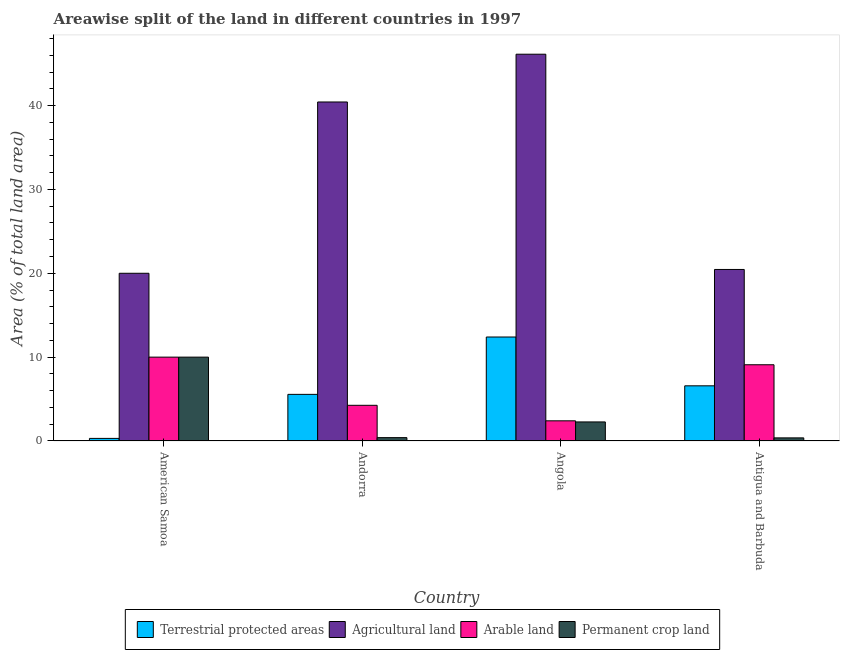How many different coloured bars are there?
Offer a very short reply. 4. Are the number of bars per tick equal to the number of legend labels?
Provide a short and direct response. Yes. How many bars are there on the 4th tick from the left?
Your answer should be very brief. 4. What is the label of the 4th group of bars from the left?
Offer a terse response. Antigua and Barbuda. What is the percentage of land under terrestrial protection in Antigua and Barbuda?
Make the answer very short. 6.58. Across all countries, what is the maximum percentage of area under permanent crop land?
Keep it short and to the point. 10. In which country was the percentage of land under terrestrial protection maximum?
Ensure brevity in your answer.  Angola. In which country was the percentage of area under agricultural land minimum?
Ensure brevity in your answer.  American Samoa. What is the total percentage of land under terrestrial protection in the graph?
Make the answer very short. 24.85. What is the difference between the percentage of area under agricultural land in Andorra and that in Antigua and Barbuda?
Make the answer very short. 19.97. What is the difference between the percentage of land under terrestrial protection in Angola and the percentage of area under permanent crop land in Andorra?
Your response must be concise. 12. What is the average percentage of area under agricultural land per country?
Provide a short and direct response. 31.75. What is the difference between the percentage of land under terrestrial protection and percentage of area under arable land in Andorra?
Keep it short and to the point. 1.3. In how many countries, is the percentage of area under permanent crop land greater than 26 %?
Make the answer very short. 0. What is the ratio of the percentage of area under agricultural land in American Samoa to that in Andorra?
Offer a very short reply. 0.49. Is the difference between the percentage of area under agricultural land in American Samoa and Andorra greater than the difference between the percentage of land under terrestrial protection in American Samoa and Andorra?
Your response must be concise. No. What is the difference between the highest and the second highest percentage of land under terrestrial protection?
Your answer should be compact. 5.82. What is the difference between the highest and the lowest percentage of area under arable land?
Make the answer very short. 7.59. Is it the case that in every country, the sum of the percentage of land under terrestrial protection and percentage of area under permanent crop land is greater than the sum of percentage of area under agricultural land and percentage of area under arable land?
Offer a terse response. Yes. What does the 3rd bar from the left in American Samoa represents?
Make the answer very short. Arable land. What does the 2nd bar from the right in American Samoa represents?
Your response must be concise. Arable land. Is it the case that in every country, the sum of the percentage of land under terrestrial protection and percentage of area under agricultural land is greater than the percentage of area under arable land?
Offer a very short reply. Yes. How many countries are there in the graph?
Give a very brief answer. 4. What is the difference between two consecutive major ticks on the Y-axis?
Offer a very short reply. 10. Are the values on the major ticks of Y-axis written in scientific E-notation?
Your response must be concise. No. Where does the legend appear in the graph?
Provide a short and direct response. Bottom center. How many legend labels are there?
Provide a short and direct response. 4. What is the title of the graph?
Your answer should be compact. Areawise split of the land in different countries in 1997. Does "Forest" appear as one of the legend labels in the graph?
Your response must be concise. No. What is the label or title of the Y-axis?
Your response must be concise. Area (% of total land area). What is the Area (% of total land area) of Terrestrial protected areas in American Samoa?
Give a very brief answer. 0.31. What is the Area (% of total land area) in Agricultural land in American Samoa?
Your response must be concise. 20. What is the Area (% of total land area) of Arable land in American Samoa?
Ensure brevity in your answer.  10. What is the Area (% of total land area) of Permanent crop land in American Samoa?
Keep it short and to the point. 10. What is the Area (% of total land area) in Terrestrial protected areas in Andorra?
Give a very brief answer. 5.56. What is the Area (% of total land area) in Agricultural land in Andorra?
Provide a succinct answer. 40.43. What is the Area (% of total land area) of Arable land in Andorra?
Your response must be concise. 4.26. What is the Area (% of total land area) in Permanent crop land in Andorra?
Your answer should be compact. 0.4. What is the Area (% of total land area) of Terrestrial protected areas in Angola?
Give a very brief answer. 12.4. What is the Area (% of total land area) of Agricultural land in Angola?
Provide a short and direct response. 46.12. What is the Area (% of total land area) in Arable land in Angola?
Your answer should be very brief. 2.41. What is the Area (% of total land area) in Permanent crop land in Angola?
Offer a very short reply. 2.27. What is the Area (% of total land area) in Terrestrial protected areas in Antigua and Barbuda?
Provide a succinct answer. 6.58. What is the Area (% of total land area) in Agricultural land in Antigua and Barbuda?
Ensure brevity in your answer.  20.45. What is the Area (% of total land area) of Arable land in Antigua and Barbuda?
Your answer should be compact. 9.09. What is the Area (% of total land area) in Permanent crop land in Antigua and Barbuda?
Ensure brevity in your answer.  0.37. Across all countries, what is the maximum Area (% of total land area) of Terrestrial protected areas?
Your answer should be compact. 12.4. Across all countries, what is the maximum Area (% of total land area) of Agricultural land?
Offer a terse response. 46.12. Across all countries, what is the maximum Area (% of total land area) of Permanent crop land?
Provide a succinct answer. 10. Across all countries, what is the minimum Area (% of total land area) of Terrestrial protected areas?
Ensure brevity in your answer.  0.31. Across all countries, what is the minimum Area (% of total land area) of Agricultural land?
Keep it short and to the point. 20. Across all countries, what is the minimum Area (% of total land area) of Arable land?
Offer a terse response. 2.41. Across all countries, what is the minimum Area (% of total land area) in Permanent crop land?
Give a very brief answer. 0.37. What is the total Area (% of total land area) of Terrestrial protected areas in the graph?
Your answer should be very brief. 24.85. What is the total Area (% of total land area) of Agricultural land in the graph?
Your answer should be compact. 127. What is the total Area (% of total land area) of Arable land in the graph?
Offer a terse response. 25.75. What is the total Area (% of total land area) in Permanent crop land in the graph?
Your answer should be compact. 13.04. What is the difference between the Area (% of total land area) in Terrestrial protected areas in American Samoa and that in Andorra?
Make the answer very short. -5.25. What is the difference between the Area (% of total land area) in Agricultural land in American Samoa and that in Andorra?
Make the answer very short. -20.43. What is the difference between the Area (% of total land area) of Arable land in American Samoa and that in Andorra?
Your answer should be compact. 5.74. What is the difference between the Area (% of total land area) in Permanent crop land in American Samoa and that in Andorra?
Give a very brief answer. 9.6. What is the difference between the Area (% of total land area) of Terrestrial protected areas in American Samoa and that in Angola?
Provide a short and direct response. -12.09. What is the difference between the Area (% of total land area) of Agricultural land in American Samoa and that in Angola?
Ensure brevity in your answer.  -26.12. What is the difference between the Area (% of total land area) of Arable land in American Samoa and that in Angola?
Make the answer very short. 7.59. What is the difference between the Area (% of total land area) in Permanent crop land in American Samoa and that in Angola?
Make the answer very short. 7.73. What is the difference between the Area (% of total land area) of Terrestrial protected areas in American Samoa and that in Antigua and Barbuda?
Keep it short and to the point. -6.27. What is the difference between the Area (% of total land area) of Agricultural land in American Samoa and that in Antigua and Barbuda?
Provide a succinct answer. -0.45. What is the difference between the Area (% of total land area) of Permanent crop land in American Samoa and that in Antigua and Barbuda?
Give a very brief answer. 9.63. What is the difference between the Area (% of total land area) in Terrestrial protected areas in Andorra and that in Angola?
Provide a short and direct response. -6.84. What is the difference between the Area (% of total land area) of Agricultural land in Andorra and that in Angola?
Make the answer very short. -5.7. What is the difference between the Area (% of total land area) of Arable land in Andorra and that in Angola?
Your response must be concise. 1.85. What is the difference between the Area (% of total land area) in Permanent crop land in Andorra and that in Angola?
Keep it short and to the point. -1.87. What is the difference between the Area (% of total land area) of Terrestrial protected areas in Andorra and that in Antigua and Barbuda?
Your answer should be very brief. -1.02. What is the difference between the Area (% of total land area) of Agricultural land in Andorra and that in Antigua and Barbuda?
Provide a succinct answer. 19.97. What is the difference between the Area (% of total land area) of Arable land in Andorra and that in Antigua and Barbuda?
Offer a very short reply. -4.84. What is the difference between the Area (% of total land area) of Permanent crop land in Andorra and that in Antigua and Barbuda?
Offer a terse response. 0.03. What is the difference between the Area (% of total land area) in Terrestrial protected areas in Angola and that in Antigua and Barbuda?
Provide a succinct answer. 5.82. What is the difference between the Area (% of total land area) in Agricultural land in Angola and that in Antigua and Barbuda?
Make the answer very short. 25.67. What is the difference between the Area (% of total land area) in Arable land in Angola and that in Antigua and Barbuda?
Provide a succinct answer. -6.68. What is the difference between the Area (% of total land area) of Permanent crop land in Angola and that in Antigua and Barbuda?
Ensure brevity in your answer.  1.9. What is the difference between the Area (% of total land area) of Terrestrial protected areas in American Samoa and the Area (% of total land area) of Agricultural land in Andorra?
Your answer should be compact. -40.12. What is the difference between the Area (% of total land area) of Terrestrial protected areas in American Samoa and the Area (% of total land area) of Arable land in Andorra?
Offer a terse response. -3.95. What is the difference between the Area (% of total land area) in Terrestrial protected areas in American Samoa and the Area (% of total land area) in Permanent crop land in Andorra?
Your response must be concise. -0.09. What is the difference between the Area (% of total land area) in Agricultural land in American Samoa and the Area (% of total land area) in Arable land in Andorra?
Provide a succinct answer. 15.74. What is the difference between the Area (% of total land area) of Agricultural land in American Samoa and the Area (% of total land area) of Permanent crop land in Andorra?
Ensure brevity in your answer.  19.6. What is the difference between the Area (% of total land area) in Arable land in American Samoa and the Area (% of total land area) in Permanent crop land in Andorra?
Offer a terse response. 9.6. What is the difference between the Area (% of total land area) of Terrestrial protected areas in American Samoa and the Area (% of total land area) of Agricultural land in Angola?
Make the answer very short. -45.81. What is the difference between the Area (% of total land area) in Terrestrial protected areas in American Samoa and the Area (% of total land area) in Arable land in Angola?
Provide a succinct answer. -2.1. What is the difference between the Area (% of total land area) of Terrestrial protected areas in American Samoa and the Area (% of total land area) of Permanent crop land in Angola?
Your response must be concise. -1.96. What is the difference between the Area (% of total land area) in Agricultural land in American Samoa and the Area (% of total land area) in Arable land in Angola?
Your answer should be very brief. 17.59. What is the difference between the Area (% of total land area) in Agricultural land in American Samoa and the Area (% of total land area) in Permanent crop land in Angola?
Your answer should be very brief. 17.73. What is the difference between the Area (% of total land area) in Arable land in American Samoa and the Area (% of total land area) in Permanent crop land in Angola?
Make the answer very short. 7.73. What is the difference between the Area (% of total land area) in Terrestrial protected areas in American Samoa and the Area (% of total land area) in Agricultural land in Antigua and Barbuda?
Your answer should be compact. -20.14. What is the difference between the Area (% of total land area) of Terrestrial protected areas in American Samoa and the Area (% of total land area) of Arable land in Antigua and Barbuda?
Make the answer very short. -8.78. What is the difference between the Area (% of total land area) in Terrestrial protected areas in American Samoa and the Area (% of total land area) in Permanent crop land in Antigua and Barbuda?
Keep it short and to the point. -0.06. What is the difference between the Area (% of total land area) in Agricultural land in American Samoa and the Area (% of total land area) in Arable land in Antigua and Barbuda?
Make the answer very short. 10.91. What is the difference between the Area (% of total land area) of Agricultural land in American Samoa and the Area (% of total land area) of Permanent crop land in Antigua and Barbuda?
Ensure brevity in your answer.  19.63. What is the difference between the Area (% of total land area) in Arable land in American Samoa and the Area (% of total land area) in Permanent crop land in Antigua and Barbuda?
Ensure brevity in your answer.  9.63. What is the difference between the Area (% of total land area) of Terrestrial protected areas in Andorra and the Area (% of total land area) of Agricultural land in Angola?
Your response must be concise. -40.56. What is the difference between the Area (% of total land area) of Terrestrial protected areas in Andorra and the Area (% of total land area) of Arable land in Angola?
Your response must be concise. 3.15. What is the difference between the Area (% of total land area) in Terrestrial protected areas in Andorra and the Area (% of total land area) in Permanent crop land in Angola?
Provide a succinct answer. 3.29. What is the difference between the Area (% of total land area) of Agricultural land in Andorra and the Area (% of total land area) of Arable land in Angola?
Ensure brevity in your answer.  38.02. What is the difference between the Area (% of total land area) in Agricultural land in Andorra and the Area (% of total land area) in Permanent crop land in Angola?
Provide a succinct answer. 38.15. What is the difference between the Area (% of total land area) in Arable land in Andorra and the Area (% of total land area) in Permanent crop land in Angola?
Ensure brevity in your answer.  1.98. What is the difference between the Area (% of total land area) of Terrestrial protected areas in Andorra and the Area (% of total land area) of Agricultural land in Antigua and Barbuda?
Make the answer very short. -14.89. What is the difference between the Area (% of total land area) in Terrestrial protected areas in Andorra and the Area (% of total land area) in Arable land in Antigua and Barbuda?
Provide a short and direct response. -3.53. What is the difference between the Area (% of total land area) in Terrestrial protected areas in Andorra and the Area (% of total land area) in Permanent crop land in Antigua and Barbuda?
Your response must be concise. 5.19. What is the difference between the Area (% of total land area) in Agricultural land in Andorra and the Area (% of total land area) in Arable land in Antigua and Barbuda?
Your response must be concise. 31.33. What is the difference between the Area (% of total land area) of Agricultural land in Andorra and the Area (% of total land area) of Permanent crop land in Antigua and Barbuda?
Make the answer very short. 40.05. What is the difference between the Area (% of total land area) of Arable land in Andorra and the Area (% of total land area) of Permanent crop land in Antigua and Barbuda?
Ensure brevity in your answer.  3.88. What is the difference between the Area (% of total land area) of Terrestrial protected areas in Angola and the Area (% of total land area) of Agricultural land in Antigua and Barbuda?
Keep it short and to the point. -8.05. What is the difference between the Area (% of total land area) of Terrestrial protected areas in Angola and the Area (% of total land area) of Arable land in Antigua and Barbuda?
Offer a very short reply. 3.31. What is the difference between the Area (% of total land area) of Terrestrial protected areas in Angola and the Area (% of total land area) of Permanent crop land in Antigua and Barbuda?
Your answer should be compact. 12.03. What is the difference between the Area (% of total land area) in Agricultural land in Angola and the Area (% of total land area) in Arable land in Antigua and Barbuda?
Your response must be concise. 37.03. What is the difference between the Area (% of total land area) in Agricultural land in Angola and the Area (% of total land area) in Permanent crop land in Antigua and Barbuda?
Keep it short and to the point. 45.75. What is the difference between the Area (% of total land area) in Arable land in Angola and the Area (% of total land area) in Permanent crop land in Antigua and Barbuda?
Ensure brevity in your answer.  2.04. What is the average Area (% of total land area) of Terrestrial protected areas per country?
Your answer should be compact. 6.21. What is the average Area (% of total land area) in Agricultural land per country?
Your response must be concise. 31.75. What is the average Area (% of total land area) of Arable land per country?
Provide a short and direct response. 6.44. What is the average Area (% of total land area) of Permanent crop land per country?
Keep it short and to the point. 3.26. What is the difference between the Area (% of total land area) of Terrestrial protected areas and Area (% of total land area) of Agricultural land in American Samoa?
Provide a short and direct response. -19.69. What is the difference between the Area (% of total land area) of Terrestrial protected areas and Area (% of total land area) of Arable land in American Samoa?
Offer a terse response. -9.69. What is the difference between the Area (% of total land area) in Terrestrial protected areas and Area (% of total land area) in Permanent crop land in American Samoa?
Ensure brevity in your answer.  -9.69. What is the difference between the Area (% of total land area) in Agricultural land and Area (% of total land area) in Arable land in American Samoa?
Offer a very short reply. 10. What is the difference between the Area (% of total land area) in Arable land and Area (% of total land area) in Permanent crop land in American Samoa?
Your answer should be very brief. 0. What is the difference between the Area (% of total land area) of Terrestrial protected areas and Area (% of total land area) of Agricultural land in Andorra?
Your answer should be very brief. -34.87. What is the difference between the Area (% of total land area) of Terrestrial protected areas and Area (% of total land area) of Arable land in Andorra?
Ensure brevity in your answer.  1.3. What is the difference between the Area (% of total land area) of Terrestrial protected areas and Area (% of total land area) of Permanent crop land in Andorra?
Keep it short and to the point. 5.16. What is the difference between the Area (% of total land area) in Agricultural land and Area (% of total land area) in Arable land in Andorra?
Give a very brief answer. 36.17. What is the difference between the Area (% of total land area) of Agricultural land and Area (% of total land area) of Permanent crop land in Andorra?
Your answer should be compact. 40.02. What is the difference between the Area (% of total land area) in Arable land and Area (% of total land area) in Permanent crop land in Andorra?
Provide a succinct answer. 3.85. What is the difference between the Area (% of total land area) of Terrestrial protected areas and Area (% of total land area) of Agricultural land in Angola?
Offer a very short reply. -33.72. What is the difference between the Area (% of total land area) of Terrestrial protected areas and Area (% of total land area) of Arable land in Angola?
Your response must be concise. 9.99. What is the difference between the Area (% of total land area) in Terrestrial protected areas and Area (% of total land area) in Permanent crop land in Angola?
Your response must be concise. 10.13. What is the difference between the Area (% of total land area) of Agricultural land and Area (% of total land area) of Arable land in Angola?
Offer a very short reply. 43.72. What is the difference between the Area (% of total land area) of Agricultural land and Area (% of total land area) of Permanent crop land in Angola?
Give a very brief answer. 43.85. What is the difference between the Area (% of total land area) of Arable land and Area (% of total land area) of Permanent crop land in Angola?
Ensure brevity in your answer.  0.13. What is the difference between the Area (% of total land area) in Terrestrial protected areas and Area (% of total land area) in Agricultural land in Antigua and Barbuda?
Your response must be concise. -13.88. What is the difference between the Area (% of total land area) in Terrestrial protected areas and Area (% of total land area) in Arable land in Antigua and Barbuda?
Offer a very short reply. -2.51. What is the difference between the Area (% of total land area) of Terrestrial protected areas and Area (% of total land area) of Permanent crop land in Antigua and Barbuda?
Offer a terse response. 6.21. What is the difference between the Area (% of total land area) of Agricultural land and Area (% of total land area) of Arable land in Antigua and Barbuda?
Provide a short and direct response. 11.36. What is the difference between the Area (% of total land area) of Agricultural land and Area (% of total land area) of Permanent crop land in Antigua and Barbuda?
Give a very brief answer. 20.08. What is the difference between the Area (% of total land area) of Arable land and Area (% of total land area) of Permanent crop land in Antigua and Barbuda?
Ensure brevity in your answer.  8.72. What is the ratio of the Area (% of total land area) in Terrestrial protected areas in American Samoa to that in Andorra?
Offer a very short reply. 0.06. What is the ratio of the Area (% of total land area) in Agricultural land in American Samoa to that in Andorra?
Make the answer very short. 0.49. What is the ratio of the Area (% of total land area) in Arable land in American Samoa to that in Andorra?
Offer a terse response. 2.35. What is the ratio of the Area (% of total land area) in Permanent crop land in American Samoa to that in Andorra?
Ensure brevity in your answer.  24.93. What is the ratio of the Area (% of total land area) in Terrestrial protected areas in American Samoa to that in Angola?
Provide a short and direct response. 0.03. What is the ratio of the Area (% of total land area) of Agricultural land in American Samoa to that in Angola?
Offer a very short reply. 0.43. What is the ratio of the Area (% of total land area) of Arable land in American Samoa to that in Angola?
Your answer should be very brief. 4.16. What is the ratio of the Area (% of total land area) in Permanent crop land in American Samoa to that in Angola?
Provide a short and direct response. 4.4. What is the ratio of the Area (% of total land area) of Terrestrial protected areas in American Samoa to that in Antigua and Barbuda?
Your response must be concise. 0.05. What is the ratio of the Area (% of total land area) of Agricultural land in American Samoa to that in Antigua and Barbuda?
Offer a very short reply. 0.98. What is the ratio of the Area (% of total land area) in Permanent crop land in American Samoa to that in Antigua and Barbuda?
Your answer should be very brief. 26.96. What is the ratio of the Area (% of total land area) in Terrestrial protected areas in Andorra to that in Angola?
Provide a succinct answer. 0.45. What is the ratio of the Area (% of total land area) of Agricultural land in Andorra to that in Angola?
Offer a very short reply. 0.88. What is the ratio of the Area (% of total land area) of Arable land in Andorra to that in Angola?
Offer a very short reply. 1.77. What is the ratio of the Area (% of total land area) in Permanent crop land in Andorra to that in Angola?
Provide a succinct answer. 0.18. What is the ratio of the Area (% of total land area) of Terrestrial protected areas in Andorra to that in Antigua and Barbuda?
Provide a short and direct response. 0.85. What is the ratio of the Area (% of total land area) in Agricultural land in Andorra to that in Antigua and Barbuda?
Offer a terse response. 1.98. What is the ratio of the Area (% of total land area) of Arable land in Andorra to that in Antigua and Barbuda?
Make the answer very short. 0.47. What is the ratio of the Area (% of total land area) in Permanent crop land in Andorra to that in Antigua and Barbuda?
Offer a very short reply. 1.08. What is the ratio of the Area (% of total land area) in Terrestrial protected areas in Angola to that in Antigua and Barbuda?
Provide a short and direct response. 1.88. What is the ratio of the Area (% of total land area) of Agricultural land in Angola to that in Antigua and Barbuda?
Your answer should be compact. 2.25. What is the ratio of the Area (% of total land area) in Arable land in Angola to that in Antigua and Barbuda?
Offer a very short reply. 0.26. What is the ratio of the Area (% of total land area) of Permanent crop land in Angola to that in Antigua and Barbuda?
Your response must be concise. 6.13. What is the difference between the highest and the second highest Area (% of total land area) of Terrestrial protected areas?
Offer a terse response. 5.82. What is the difference between the highest and the second highest Area (% of total land area) in Agricultural land?
Your answer should be very brief. 5.7. What is the difference between the highest and the second highest Area (% of total land area) of Permanent crop land?
Your response must be concise. 7.73. What is the difference between the highest and the lowest Area (% of total land area) of Terrestrial protected areas?
Ensure brevity in your answer.  12.09. What is the difference between the highest and the lowest Area (% of total land area) in Agricultural land?
Keep it short and to the point. 26.12. What is the difference between the highest and the lowest Area (% of total land area) in Arable land?
Your response must be concise. 7.59. What is the difference between the highest and the lowest Area (% of total land area) of Permanent crop land?
Offer a very short reply. 9.63. 